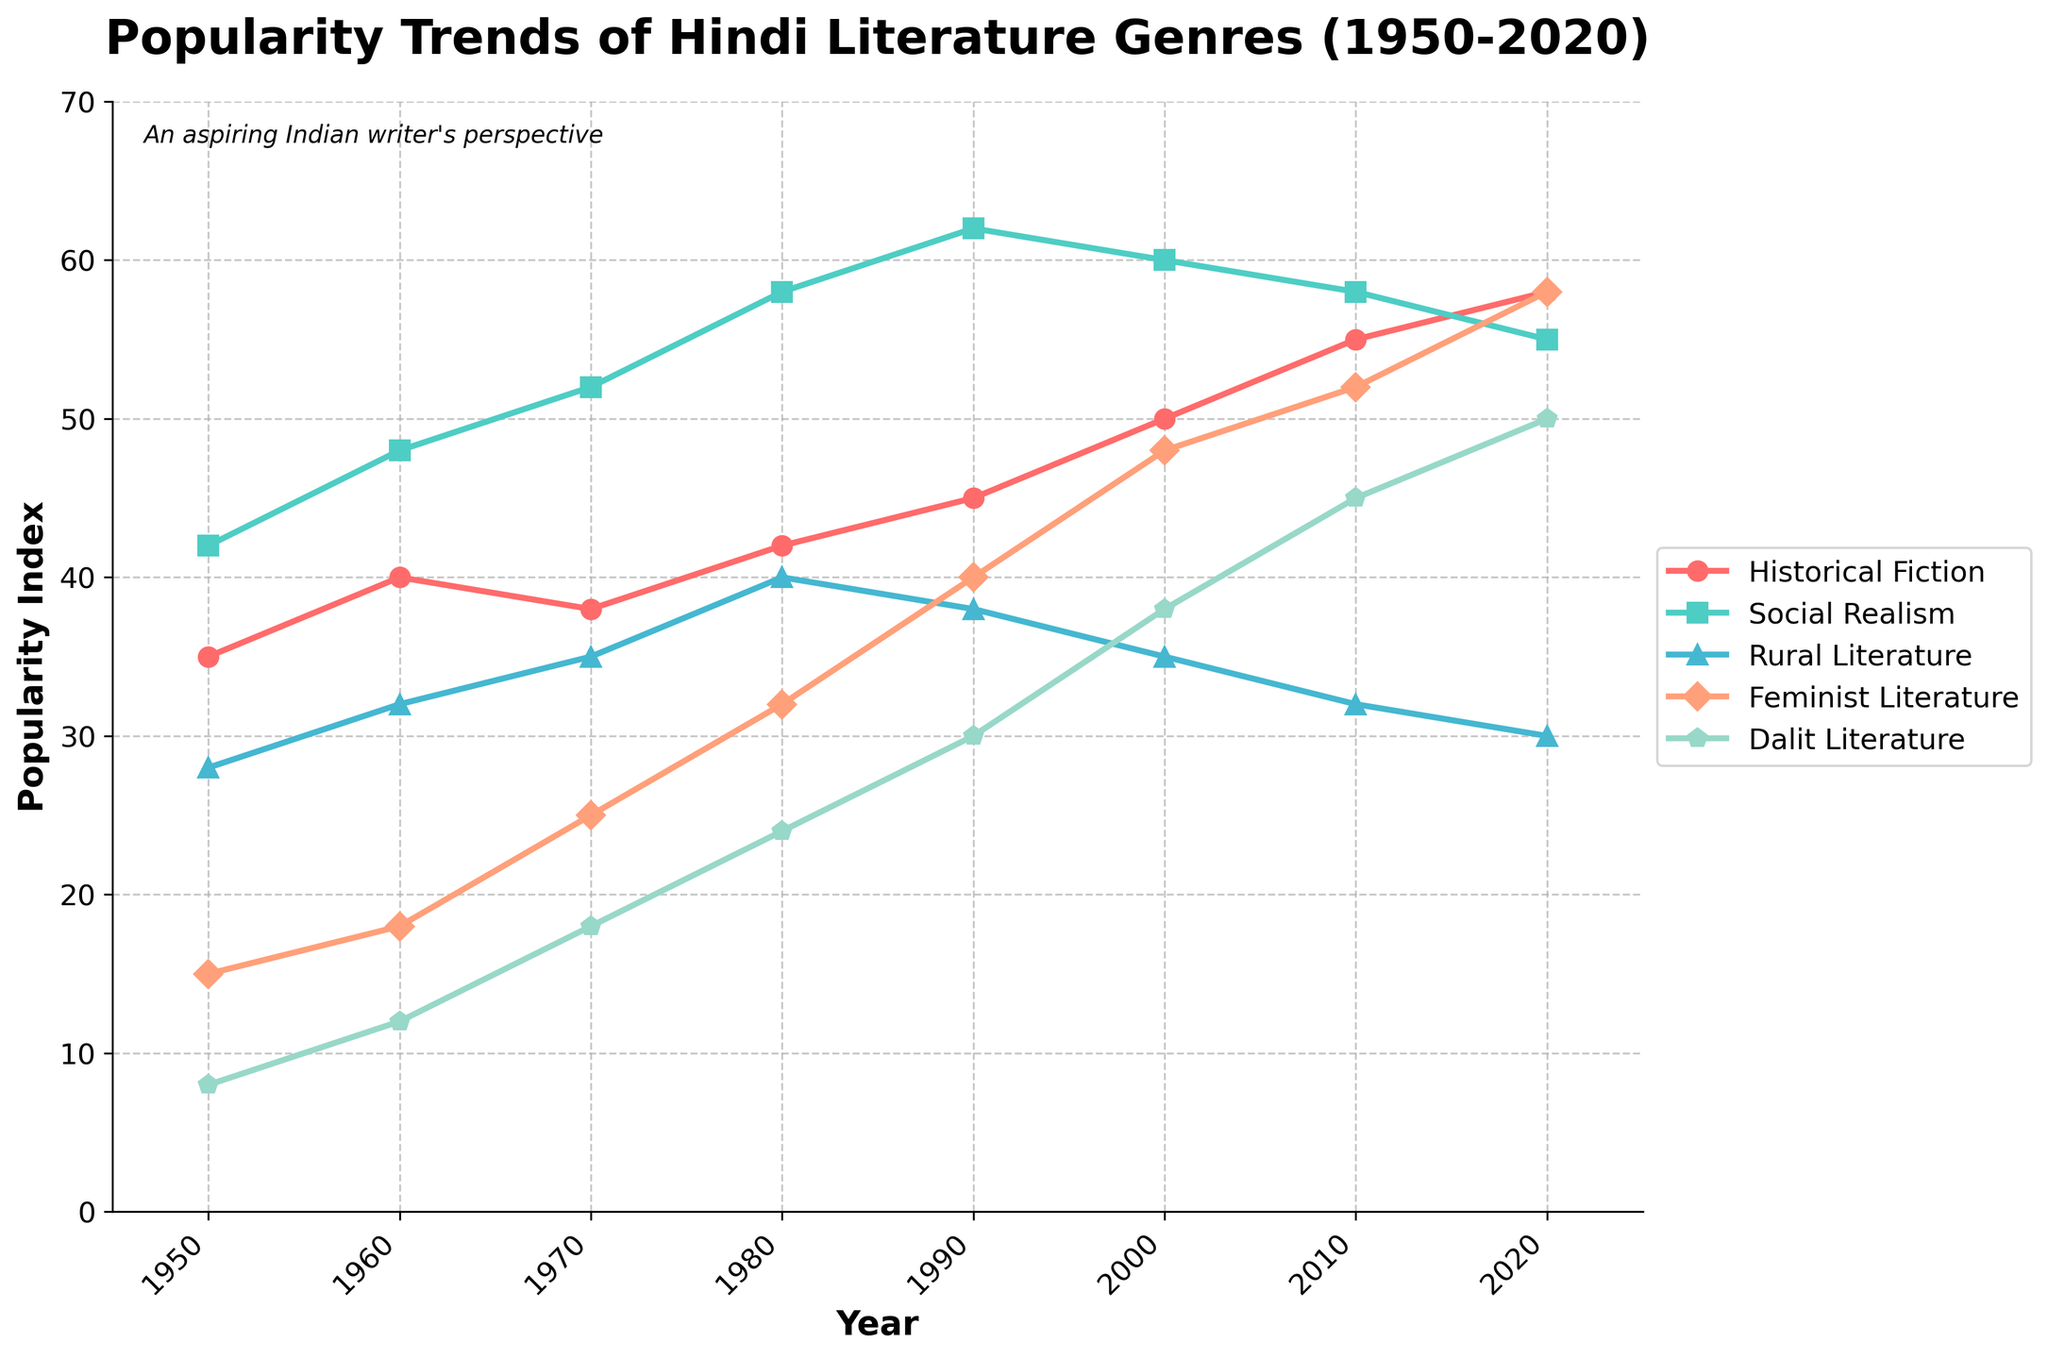Which genre had the highest popularity in 1980? The figure shows the popularity trends with different lines. For 1980, Social Realism has the highest point.
Answer: Social Realism How many genres surpassed a popularity index of 50 in 2020? By looking at the points on the graph for the year 2020, Historical Fiction, Social Realism, Feminist Literature, and Dalit Literature are above 50.
Answer: 4 What is the difference in popularity between Social Realism and Rural Literature in 1970? For 1970, Social Realism is at 52 and Rural Literature is at 35. The difference is 52 - 35.
Answer: 17 Which genre showed the most consistent upward trend from 1950 to 2020? By evaluating the slopes of all lines over the years, all genres show growth, but Historical Fiction has a consistent upward trend without any dips.
Answer: Historical Fiction What genre had a decline in popularity between 1990 and 2000? By comparing the data points from 1990 to 2000, Social Realism dropped from 62 to 60 and Rural Literature dropped from 38 to 35.
Answer: Social Realism and Rural Literature How did the popularity of Feminist Literature change from 1980 to 2000? From 1980 to 2000, Feminist Literature grew from 32 to 48.
Answer: Increased Which year showed the greatest popularity increase for Dalit Literature? By comparing the yearly data points for Dalit Literature, the greatest increase is from 2000 to 2010, jumping from 38 to 45.
Answer: 2000 to 2010 What was the average popularity of Rural Literature between 1950 and 2020? Adding all popularity values of Rural Literature (28+32+35+40+38+35+32+30) and dividing by 8 gives the average.
Answer: 33.75 In which decade did Historical Fiction see its highest growth in popularity index? Comparing decade-to-decade growth for Historical Fiction, the highest growth is seen from 2000 to 2010, growing from 50 to 55.
Answer: 2000 to 2010 